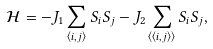Convert formula to latex. <formula><loc_0><loc_0><loc_500><loc_500>\mathcal { H } = - J _ { 1 } \sum _ { \langle i , j \rangle } S _ { i } S _ { j } - J _ { 2 } \sum _ { \langle \langle i , j \rangle \rangle } S _ { i } S _ { j } ,</formula> 